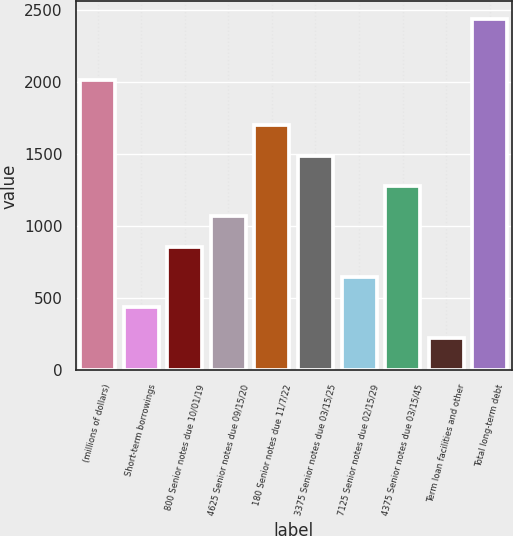<chart> <loc_0><loc_0><loc_500><loc_500><bar_chart><fcel>(millions of dollars)<fcel>Short-term borrowings<fcel>800 Senior notes due 10/01/19<fcel>4625 Senior notes due 09/15/20<fcel>180 Senior notes due 11/7/22<fcel>3375 Senior notes due 03/15/25<fcel>7125 Senior notes due 02/15/29<fcel>4375 Senior notes due 03/15/45<fcel>Term loan facilities and other<fcel>Total long-term debt<nl><fcel>2017<fcel>436.54<fcel>857.28<fcel>1067.65<fcel>1698.76<fcel>1488.39<fcel>646.91<fcel>1278.02<fcel>226.17<fcel>2437.74<nl></chart> 